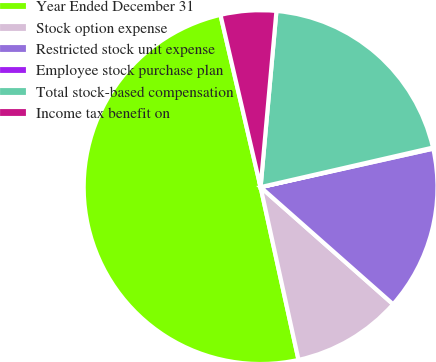<chart> <loc_0><loc_0><loc_500><loc_500><pie_chart><fcel>Year Ended December 31<fcel>Stock option expense<fcel>Restricted stock unit expense<fcel>Employee stock purchase plan<fcel>Total stock-based compensation<fcel>Income tax benefit on<nl><fcel>49.8%<fcel>10.04%<fcel>15.01%<fcel>0.1%<fcel>19.98%<fcel>5.07%<nl></chart> 